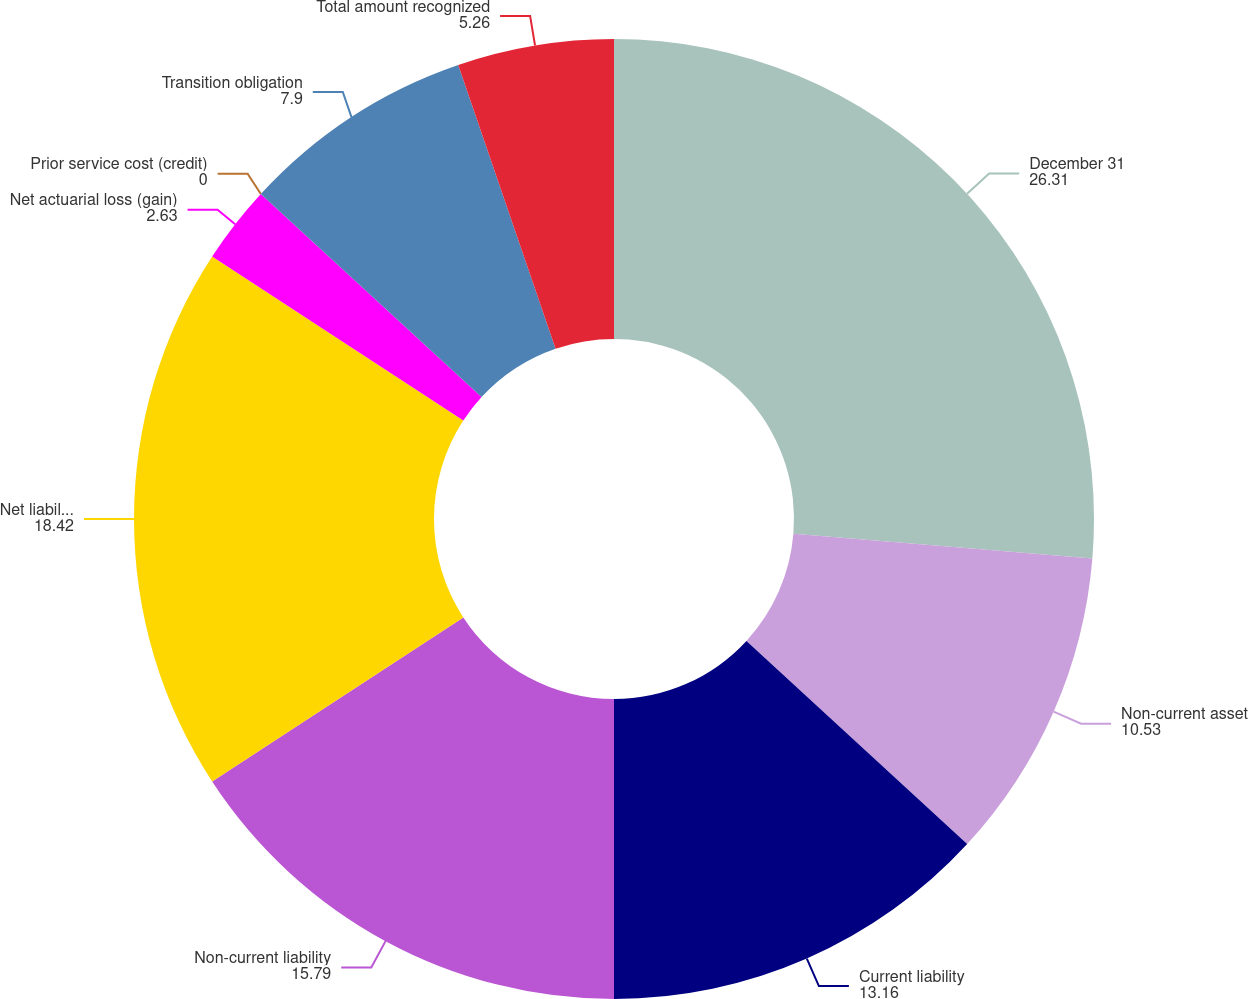Convert chart to OTSL. <chart><loc_0><loc_0><loc_500><loc_500><pie_chart><fcel>December 31<fcel>Non-current asset<fcel>Current liability<fcel>Non-current liability<fcel>Net liability recognized<fcel>Net actuarial loss (gain)<fcel>Prior service cost (credit)<fcel>Transition obligation<fcel>Total amount recognized<nl><fcel>26.31%<fcel>10.53%<fcel>13.16%<fcel>15.79%<fcel>18.42%<fcel>2.63%<fcel>0.0%<fcel>7.9%<fcel>5.26%<nl></chart> 